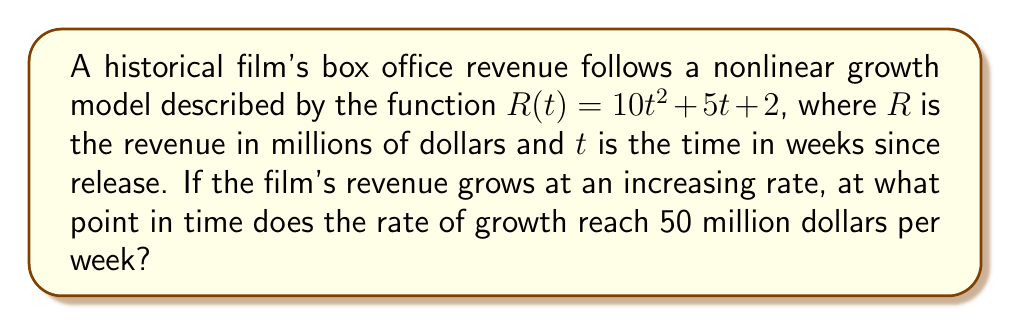Can you solve this math problem? To solve this problem, we need to follow these steps:

1) The rate of growth is represented by the derivative of the revenue function. Let's find $R'(t)$:

   $R'(t) = \frac{d}{dt}(10t^2 + 5t + 2) = 20t + 5$

2) We're told that the rate of growth is increasing. This means the second derivative should be positive:

   $R''(t) = \frac{d}{dt}(20t + 5) = 20$

   Indeed, $R''(t)$ is positive, confirming the increasing rate of growth.

3) We want to find when the rate of growth reaches 50 million dollars per week. This means we need to solve the equation:

   $R'(t) = 50$

4) Substituting our expression for $R'(t)$:

   $20t + 5 = 50$

5) Solving for $t$:

   $20t = 45$
   $t = \frac{45}{20} = 2.25$

Therefore, the rate of growth reaches 50 million dollars per week after 2.25 weeks.
Answer: 2.25 weeks 